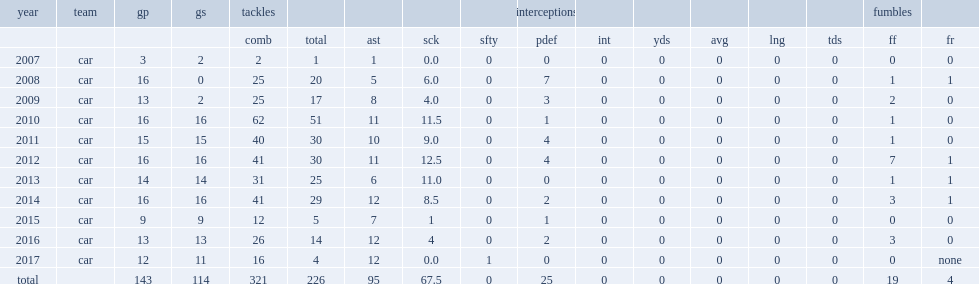What was the record of johnson in 2011? 9.0. 